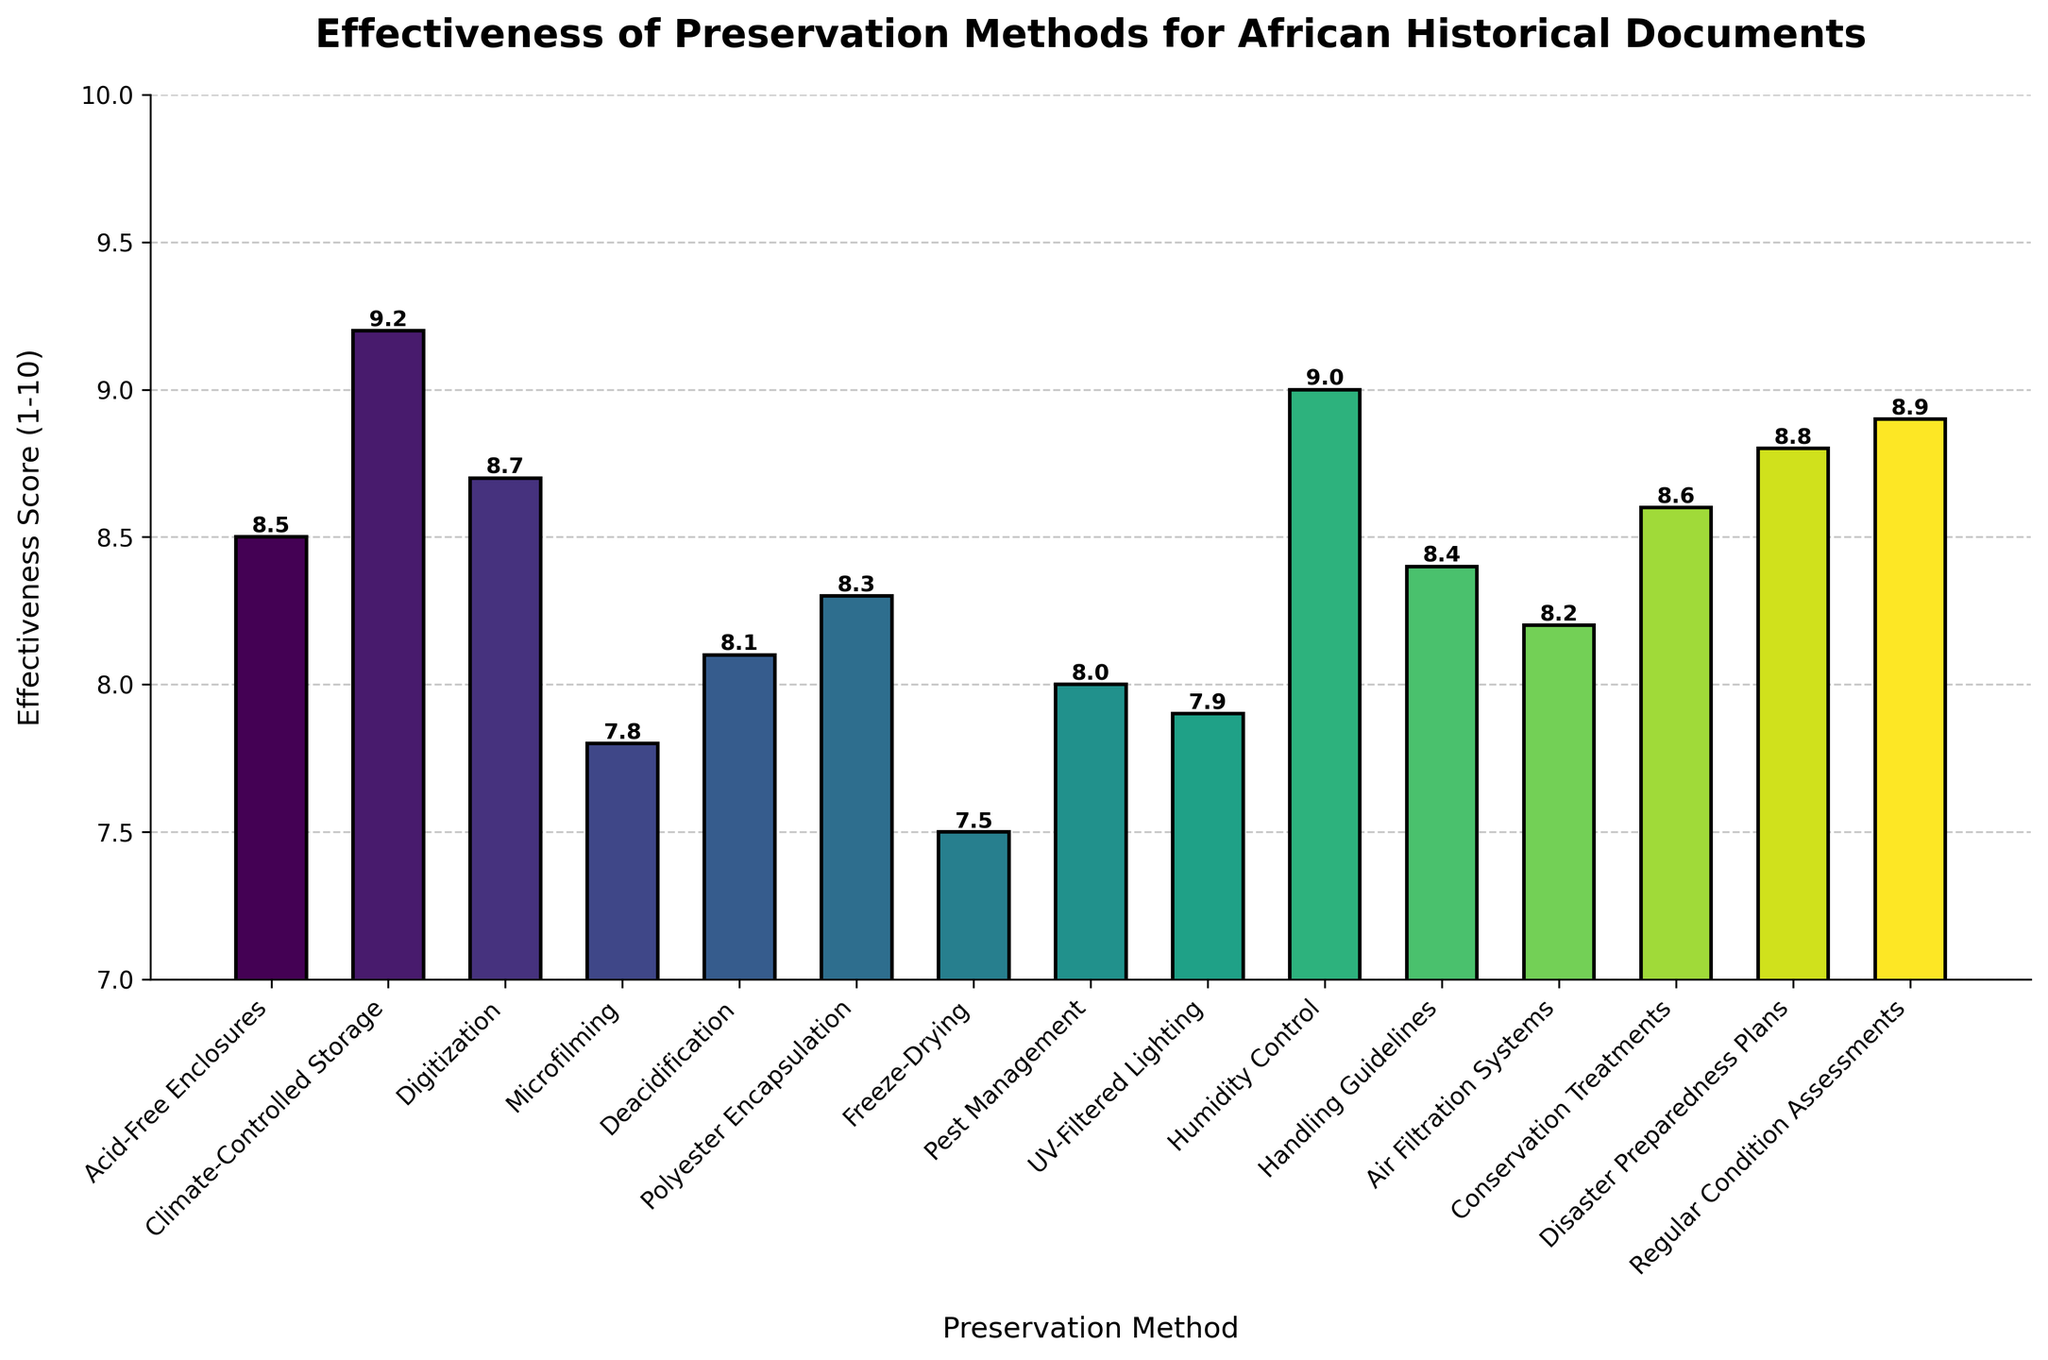What is the highest effectiveness score among the preservation methods? Locate the tallest bar in the bar chart, which corresponds to the highest effectiveness score. The label and the height of this bar will show the preservation method and its score. The tallest bar is labeled "Climate-Controlled Storage" with a score of 9.2.
Answer: 9.2 Which preservation method has the lowest effectiveness score? Find the shortest bar in the bar chart to identify the preservation method with the lowest effectiveness score. The label and the height of this bar will indicate the method and its score. The shortest bar is "Freeze-Drying" with a score of 7.5.
Answer: Freeze-Drying How much higher is the effectiveness score of Handling Guidelines compared to Pest Management? Locate the bars for "Handling Guidelines" and "Pest Management." Note their heights: 8.4 and 8.0, respectively. Subtract the effectiveness score of "Pest Management" from "Handling Guidelines" to get the difference: 8.4 - 8.0 = 0.4.
Answer: 0.4 What is the average effectiveness score of the top three methods? Identify the top three bars by height, which are "Climate-Controlled Storage" (9.2), "Disaster Preparedness Plans" (8.8), and "Regular Condition Assessments" (8.9). Sum their scores and divide by 3 to find the average: (9.2 + 8.8 + 8.9) / 3 = 8.967.
Answer: 8.967 How many preservation methods have an effectiveness score of 8.5 or higher? Count the number of bars with heights equal to or exceeding 8.5. These methods are: "Acid-Free Enclosures" (8.5), "Digitization" (8.7), "Conservation Treatments" (8.6), "Disaster Preparedness Plans" (8.8), "Regular Condition Assessments" (8.9), and "Climate-Controlled Storage" (9.2). This gives a total of 6 bars.
Answer: 6 Does Polyester Encapsulation have a higher effectiveness score than Deacidification? Compare the heights of the bars for "Polyester Encapsulation" (8.3) and "Deacidification" (8.1). "Polyester Encapsulation" has a higher score than "Deacidification."
Answer: Yes What is the combined effectiveness score of UV-Filtered Lighting and Air Filtration Systems? Locate the bars for "UV-Filtered Lighting" (7.9) and "Air Filtration Systems" (8.2). Add their scores together to find the sum: 7.9 + 8.2 = 16.1.
Answer: 16.1 How does the effectiveness score of Deacidification compare to Freeze-Drying? Compare the heights of the bars for "Deacidification" (8.1) and "Freeze-Drying" (7.5). "Deacidification" has a higher score than "Freeze-Drying."
Answer: Deacidification is higher 